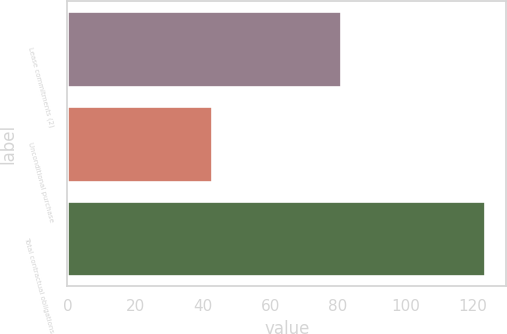Convert chart. <chart><loc_0><loc_0><loc_500><loc_500><bar_chart><fcel>Lease commitments (2)<fcel>Unconditional purchase<fcel>Total contractual obligations<nl><fcel>80.9<fcel>42.7<fcel>123.6<nl></chart> 